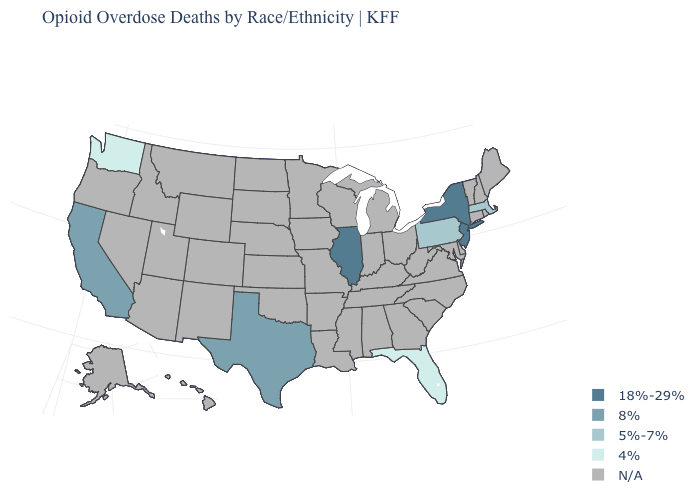Does New Jersey have the highest value in the Northeast?
Short answer required. Yes. Which states hav the highest value in the South?
Short answer required. Texas. Name the states that have a value in the range 4%?
Give a very brief answer. Florida, Washington. Does Washington have the lowest value in the West?
Short answer required. Yes. What is the highest value in the West ?
Write a very short answer. 8%. Does the first symbol in the legend represent the smallest category?
Give a very brief answer. No. Does the map have missing data?
Concise answer only. Yes. Name the states that have a value in the range 18%-29%?
Quick response, please. Illinois, New Jersey, New York. How many symbols are there in the legend?
Keep it brief. 5. What is the highest value in the West ?
Give a very brief answer. 8%. Among the states that border Delaware , which have the highest value?
Give a very brief answer. New Jersey. Is the legend a continuous bar?
Keep it brief. No. 